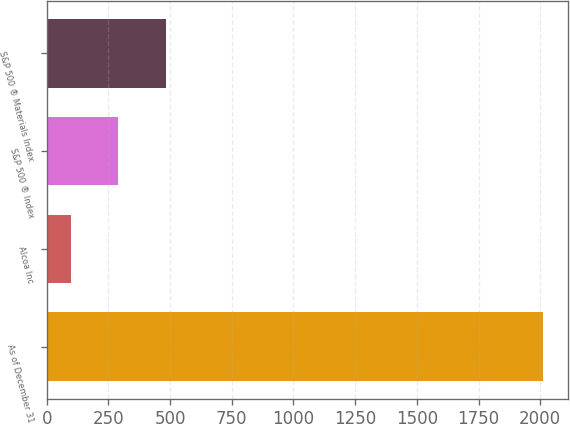Convert chart. <chart><loc_0><loc_0><loc_500><loc_500><bar_chart><fcel>As of December 31<fcel>Alcoa Inc<fcel>S&P 500 ® Index<fcel>S&P 500 ® Materials Index<nl><fcel>2010<fcel>100<fcel>291<fcel>482<nl></chart> 